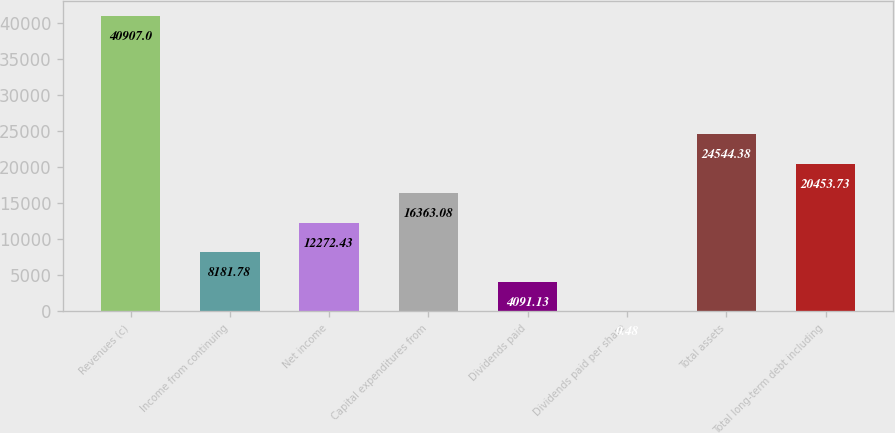Convert chart. <chart><loc_0><loc_0><loc_500><loc_500><bar_chart><fcel>Revenues (c)<fcel>Income from continuing<fcel>Net income<fcel>Capital expenditures from<fcel>Dividends paid<fcel>Dividends paid per share<fcel>Total assets<fcel>Total long-term debt including<nl><fcel>40907<fcel>8181.78<fcel>12272.4<fcel>16363.1<fcel>4091.13<fcel>0.48<fcel>24544.4<fcel>20453.7<nl></chart> 